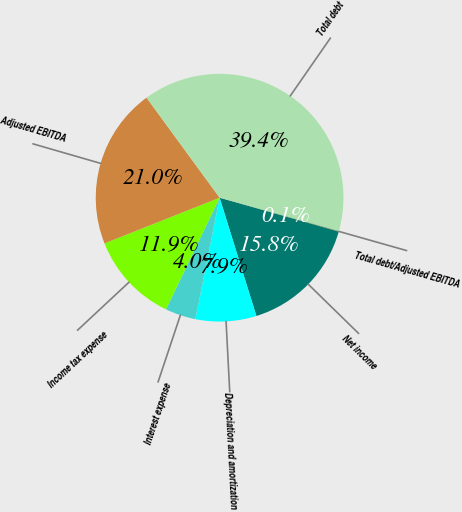<chart> <loc_0><loc_0><loc_500><loc_500><pie_chart><fcel>Net income<fcel>Depreciation and amortization<fcel>Interest expense<fcel>Income tax expense<fcel>Adjusted EBITDA<fcel>Total debt<fcel>Total debt/Adjusted EBITDA<nl><fcel>15.79%<fcel>7.93%<fcel>3.99%<fcel>11.86%<fcel>20.97%<fcel>39.4%<fcel>0.06%<nl></chart> 